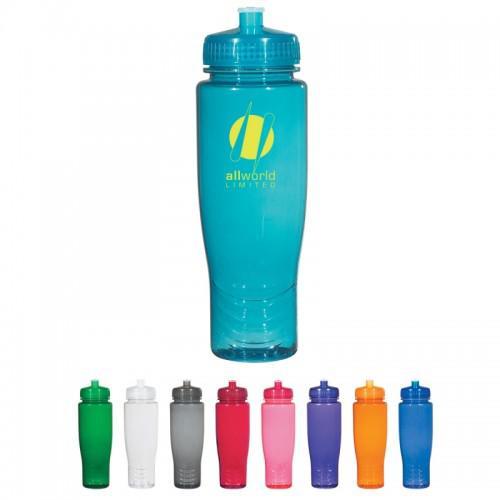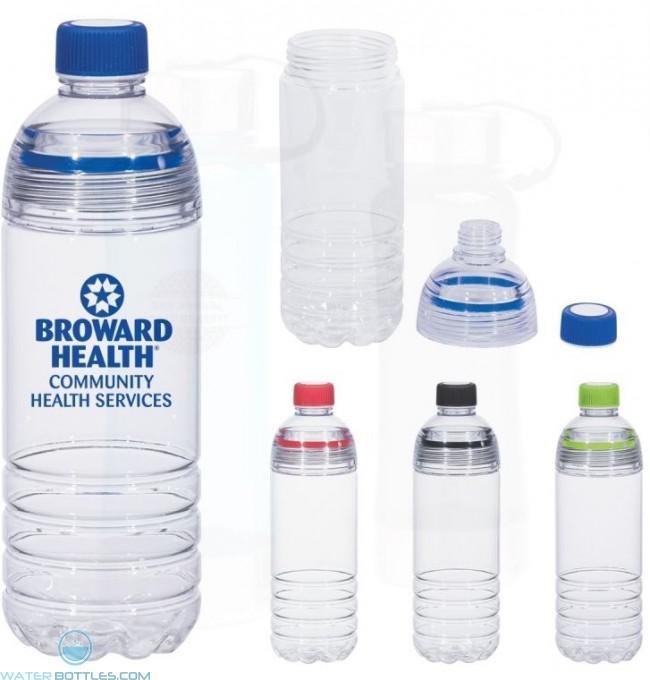The first image is the image on the left, the second image is the image on the right. For the images shown, is this caption "In at least one image there are at least two plastic bottles with no lids." true? Answer yes or no. No. 